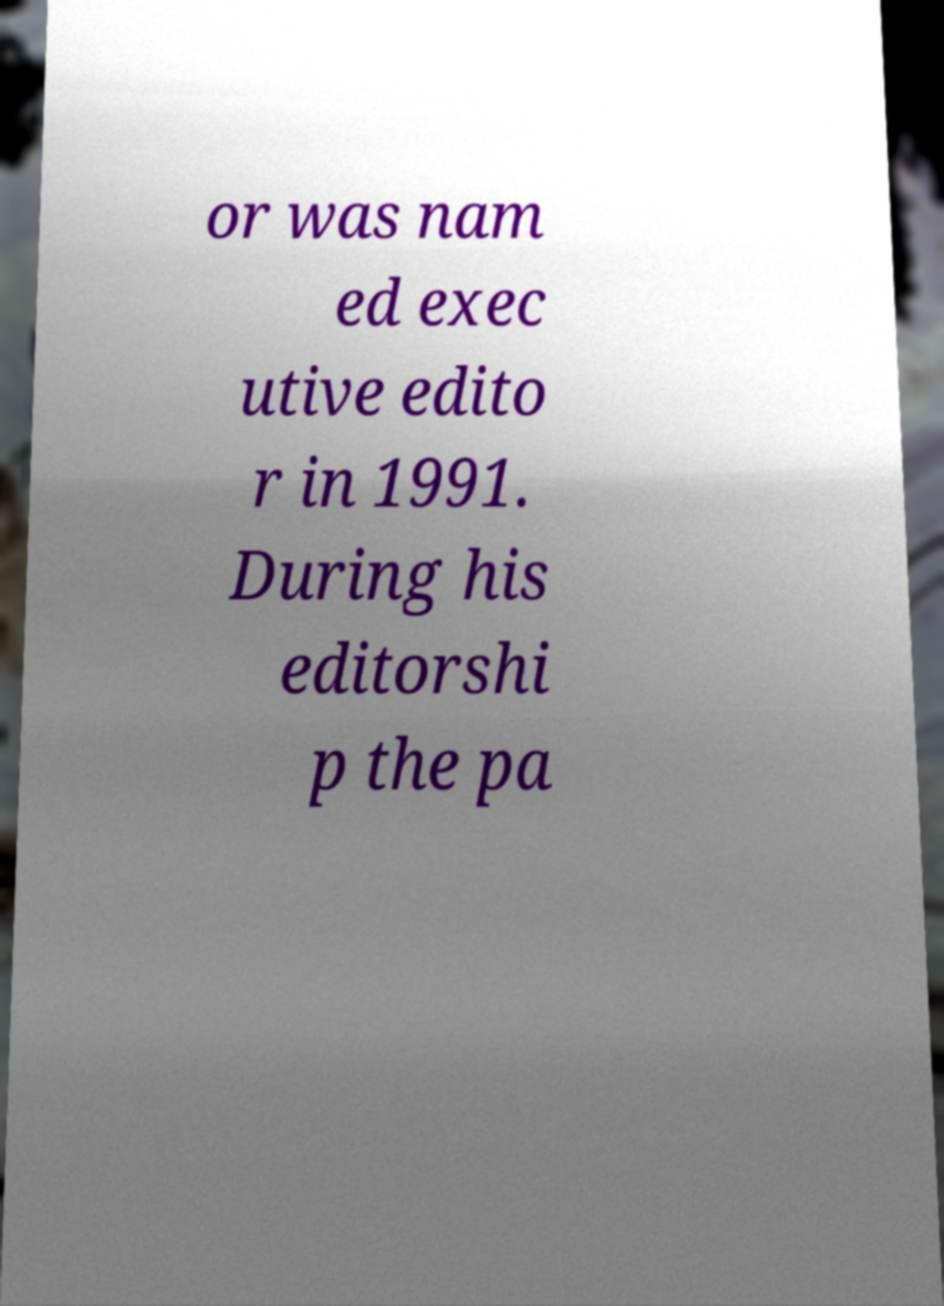I need the written content from this picture converted into text. Can you do that? or was nam ed exec utive edito r in 1991. During his editorshi p the pa 